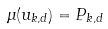<formula> <loc_0><loc_0><loc_500><loc_500>\Upsilon ( u _ { k , d } ) = P _ { k , d }</formula> 